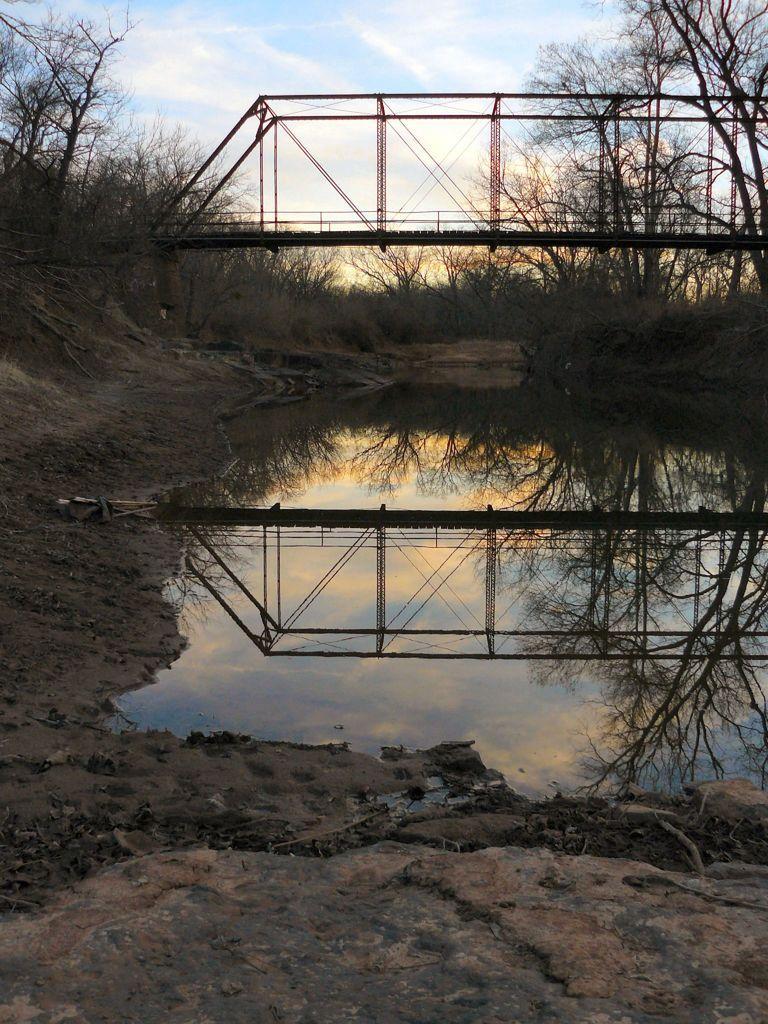How would you summarize this image in a sentence or two? In this picture we can see water, around we can see some trees and we can see bridge. 